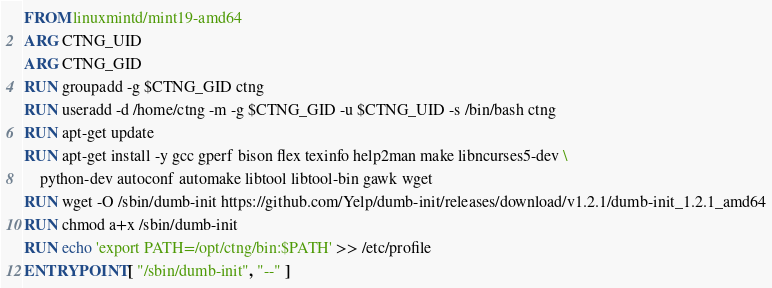Convert code to text. <code><loc_0><loc_0><loc_500><loc_500><_Dockerfile_>FROM linuxmintd/mint19-amd64
ARG CTNG_UID
ARG CTNG_GID
RUN groupadd -g $CTNG_GID ctng
RUN useradd -d /home/ctng -m -g $CTNG_GID -u $CTNG_UID -s /bin/bash ctng
RUN apt-get update
RUN apt-get install -y gcc gperf bison flex texinfo help2man make libncurses5-dev \
    python-dev autoconf automake libtool libtool-bin gawk wget
RUN wget -O /sbin/dumb-init https://github.com/Yelp/dumb-init/releases/download/v1.2.1/dumb-init_1.2.1_amd64
RUN chmod a+x /sbin/dumb-init
RUN echo 'export PATH=/opt/ctng/bin:$PATH' >> /etc/profile
ENTRYPOINT [ "/sbin/dumb-init", "--" ]
</code> 